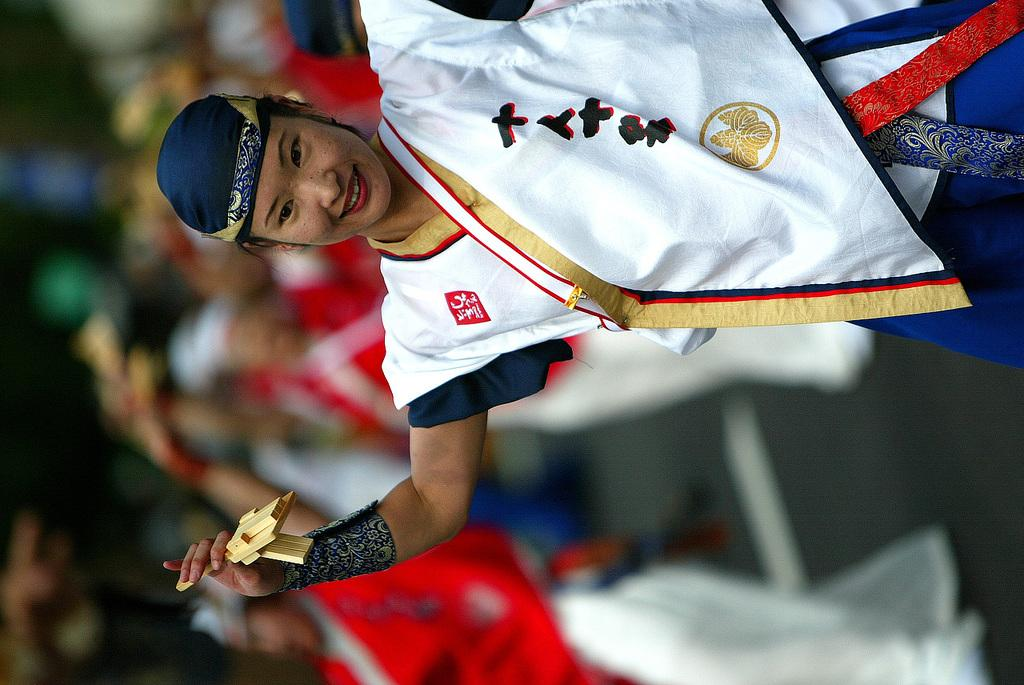Who is the main subject in the image? There is a woman in the image. What is the woman holding in her hand? The woman is holding an object in her hand. Can you describe the setting in the background of the image? There is a group of people in the background of the image, and they are standing on the ground. What type of lettuce can be seen growing in the image? There is no lettuce present in the image. What kind of beast is visible in the background of the image? There is no beast present in the image. 